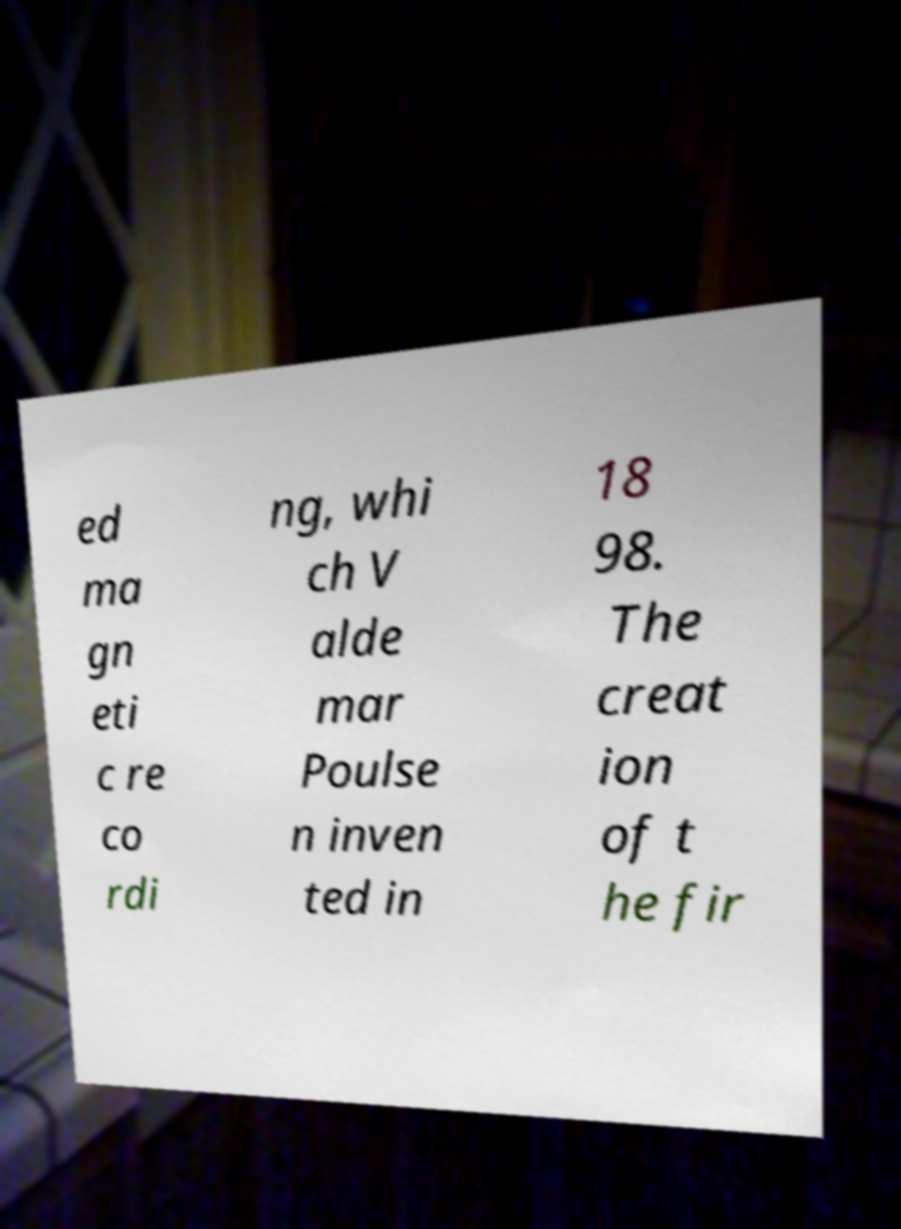Please identify and transcribe the text found in this image. ed ma gn eti c re co rdi ng, whi ch V alde mar Poulse n inven ted in 18 98. The creat ion of t he fir 